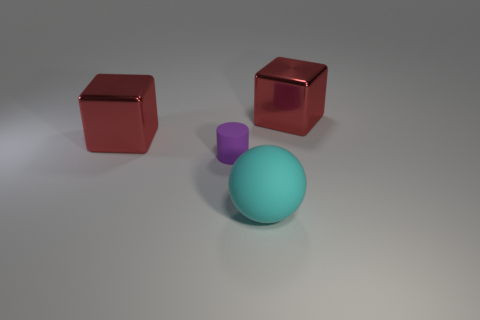How many things are rubber objects in front of the purple rubber thing or objects that are behind the tiny rubber object? 3 